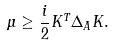<formula> <loc_0><loc_0><loc_500><loc_500>\mu \geq \frac { i } { 2 } K ^ { T } \Delta _ { A } K .</formula> 